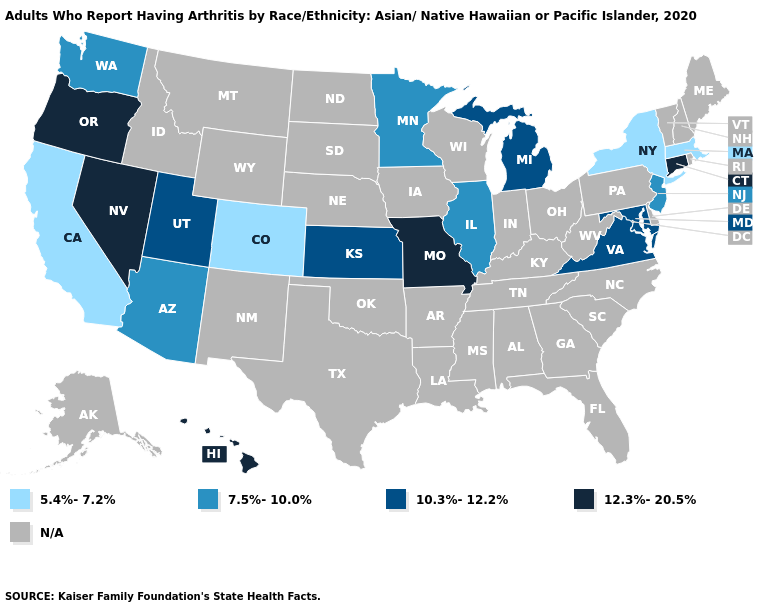Name the states that have a value in the range 10.3%-12.2%?
Short answer required. Kansas, Maryland, Michigan, Utah, Virginia. Does Oregon have the highest value in the West?
Keep it brief. Yes. Name the states that have a value in the range N/A?
Write a very short answer. Alabama, Alaska, Arkansas, Delaware, Florida, Georgia, Idaho, Indiana, Iowa, Kentucky, Louisiana, Maine, Mississippi, Montana, Nebraska, New Hampshire, New Mexico, North Carolina, North Dakota, Ohio, Oklahoma, Pennsylvania, Rhode Island, South Carolina, South Dakota, Tennessee, Texas, Vermont, West Virginia, Wisconsin, Wyoming. What is the value of Kansas?
Answer briefly. 10.3%-12.2%. What is the highest value in states that border Ohio?
Be succinct. 10.3%-12.2%. What is the highest value in the MidWest ?
Write a very short answer. 12.3%-20.5%. Among the states that border Kansas , does Missouri have the highest value?
Keep it brief. Yes. Which states have the lowest value in the Northeast?
Concise answer only. Massachusetts, New York. Does Connecticut have the highest value in the USA?
Be succinct. Yes. Name the states that have a value in the range 10.3%-12.2%?
Be succinct. Kansas, Maryland, Michigan, Utah, Virginia. Name the states that have a value in the range 5.4%-7.2%?
Give a very brief answer. California, Colorado, Massachusetts, New York. Which states have the lowest value in the West?
Concise answer only. California, Colorado. What is the value of Virginia?
Keep it brief. 10.3%-12.2%. What is the value of Rhode Island?
Concise answer only. N/A. What is the value of North Dakota?
Answer briefly. N/A. 